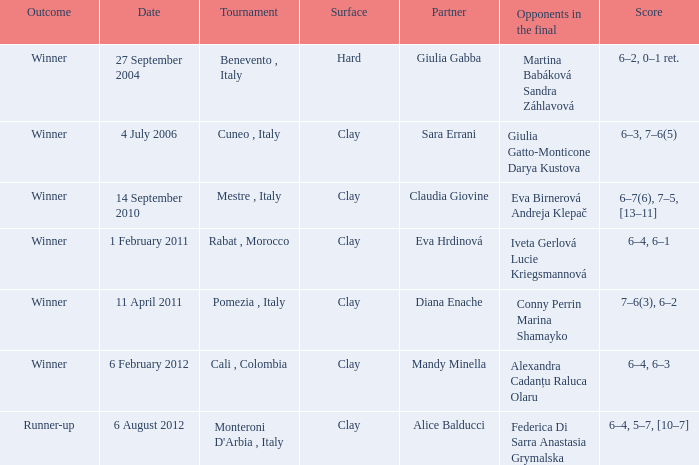Who played on a hard surface? Giulia Gabba. 